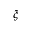<formula> <loc_0><loc_0><loc_500><loc_500>\xi</formula> 